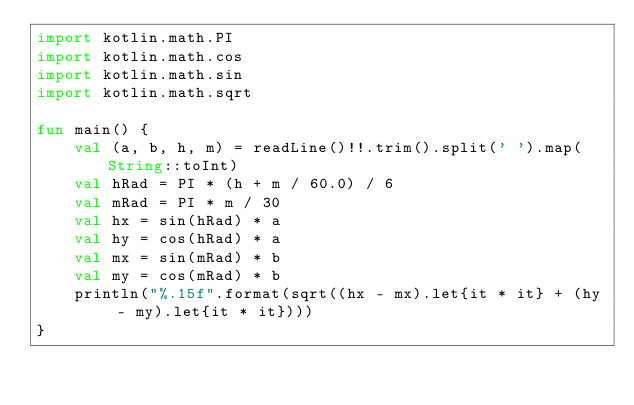<code> <loc_0><loc_0><loc_500><loc_500><_Kotlin_>import kotlin.math.PI
import kotlin.math.cos
import kotlin.math.sin
import kotlin.math.sqrt

fun main() {
    val (a, b, h, m) = readLine()!!.trim().split(' ').map(String::toInt)
    val hRad = PI * (h + m / 60.0) / 6
    val mRad = PI * m / 30
    val hx = sin(hRad) * a
    val hy = cos(hRad) * a
    val mx = sin(mRad) * b
    val my = cos(mRad) * b
    println("%.15f".format(sqrt((hx - mx).let{it * it} + (hy - my).let{it * it})))
}</code> 